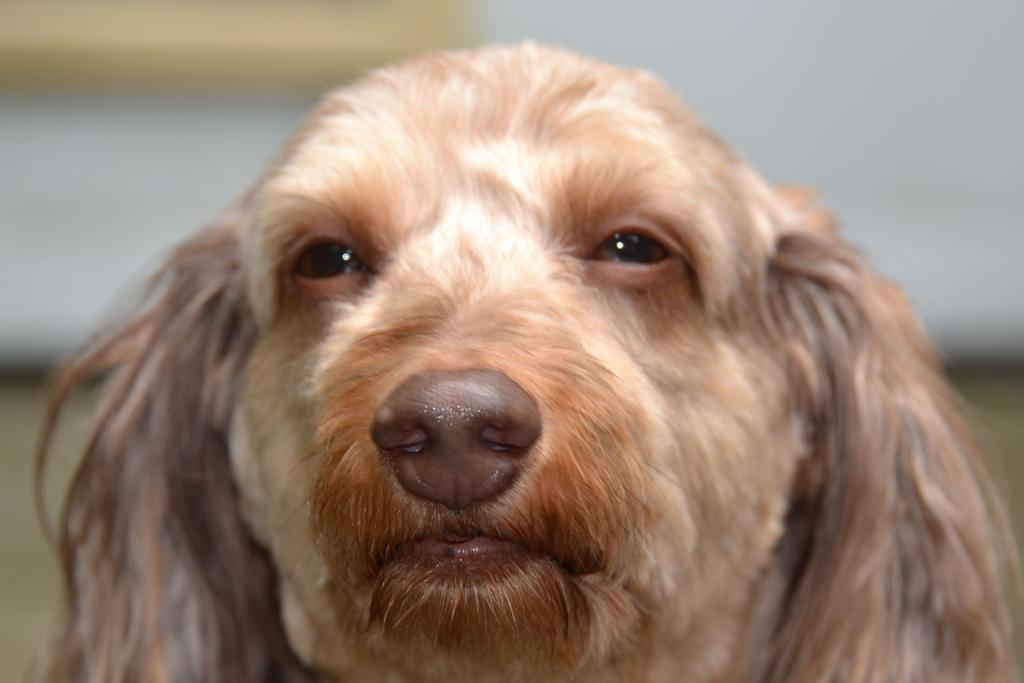How would you summarize this image in a sentence or two? In this picture, we see a brown dog. We can only see the ears, eyes, mouth and nose of the dog. In the background, it is white in color and this picture is blurred in the background. 